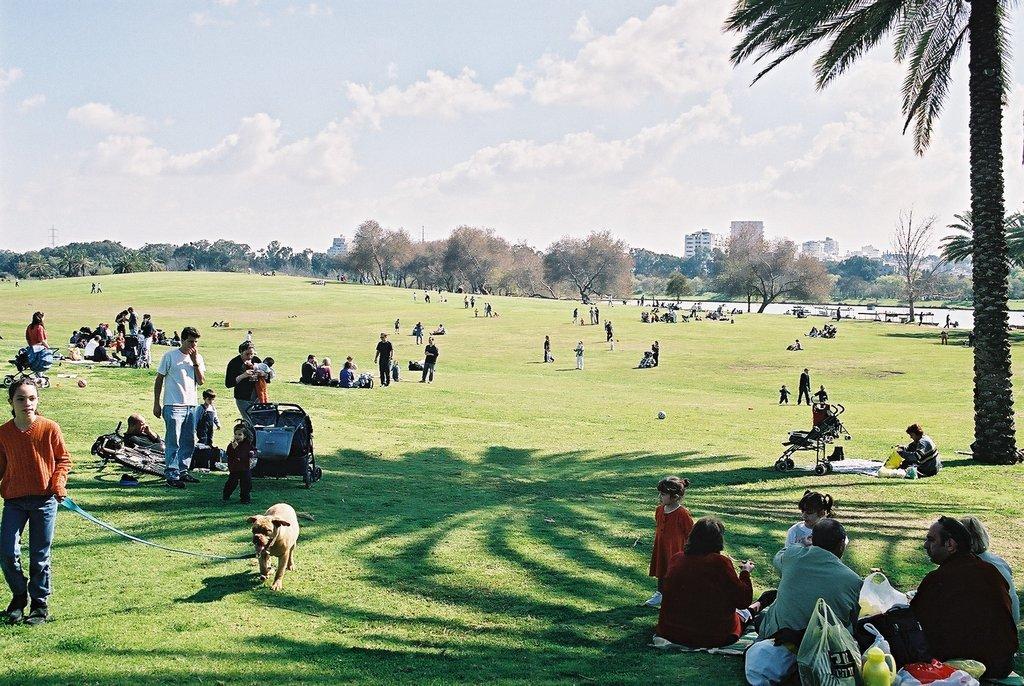Could you give a brief overview of what you see in this image? This is a picture taken in a park. In the foreground of the picture there are people, kids, carts, mats, bags, a dog and other objects. In the center of the picture there are trees, water and objects. On the right there is a tree. Sky is it cloudy and it is sunny. 